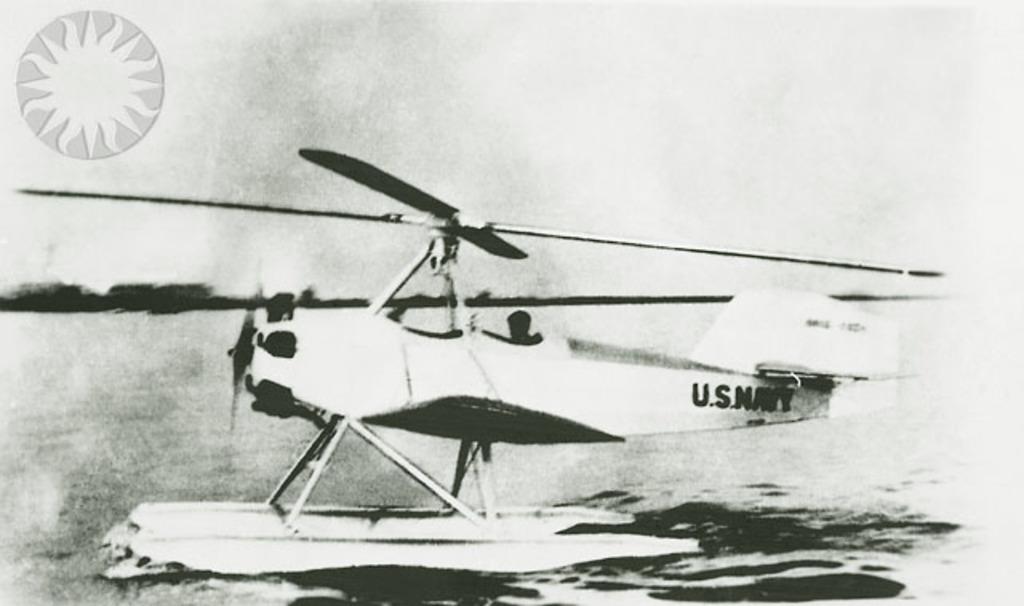Please provide a concise description of this image. It is a black and white image. In this image there is a helicopter in the water and at the left side there is a logo and at the background there are trees. 